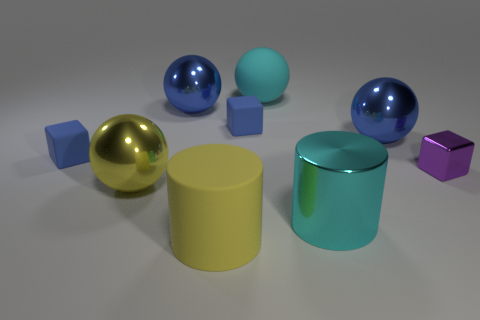Does the yellow shiny object have the same shape as the cyan object that is behind the big metal cylinder? yes 